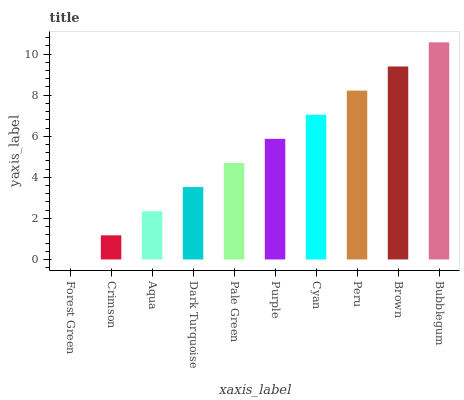Is Forest Green the minimum?
Answer yes or no. Yes. Is Bubblegum the maximum?
Answer yes or no. Yes. Is Crimson the minimum?
Answer yes or no. No. Is Crimson the maximum?
Answer yes or no. No. Is Crimson greater than Forest Green?
Answer yes or no. Yes. Is Forest Green less than Crimson?
Answer yes or no. Yes. Is Forest Green greater than Crimson?
Answer yes or no. No. Is Crimson less than Forest Green?
Answer yes or no. No. Is Purple the high median?
Answer yes or no. Yes. Is Pale Green the low median?
Answer yes or no. Yes. Is Brown the high median?
Answer yes or no. No. Is Cyan the low median?
Answer yes or no. No. 